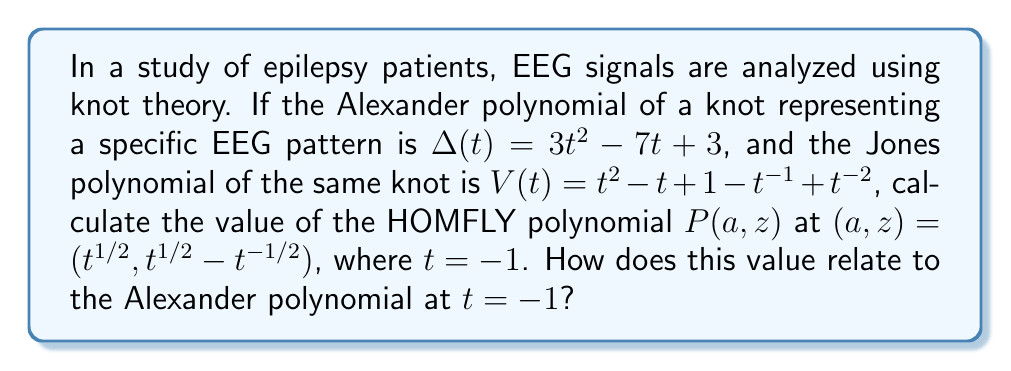What is the answer to this math problem? Let's approach this step-by-step:

1) First, we need to calculate the Alexander polynomial at $t = -1$:
   $\Delta(-1) = 3(-1)^2 - 7(-1) + 3 = 3 + 7 + 3 = 13$

2) Now, let's calculate the Jones polynomial at $t = -1$:
   $V(-1) = (-1)^2 - (-1) + 1 - (-1)^{-1} + (-1)^{-2} = 1 + 1 + 1 - 1 + 1 = 3$

3) For the HOMFLY polynomial, we need to substitute $a = t^{1/2}$ and $z = t^{1/2} - t^{-1/2}$ with $t = -1$:
   $a = (-1)^{1/2} = i$
   $z = (-1)^{1/2} - (-1)^{-1/2} = i - (-i) = 2i$

4) The HOMFLY polynomial is related to the Alexander and Jones polynomials by the following equation:
   $P(it^{1/2}, t^{1/2} - t^{-1/2}) = \Delta(t)$

5) Therefore, at $t = -1$:
   $P(i, 2i) = \Delta(-1) = 13$

6) We can verify this relationship:
   $P(i, 2i) = 13 = \Delta(-1)$

This demonstrates that the value of the HOMFLY polynomial at $(a,z) = (i, 2i)$ is equal to the value of the Alexander polynomial at $t = -1$, which is 13.
Answer: $P(i, 2i) = 13 = \Delta(-1)$ 